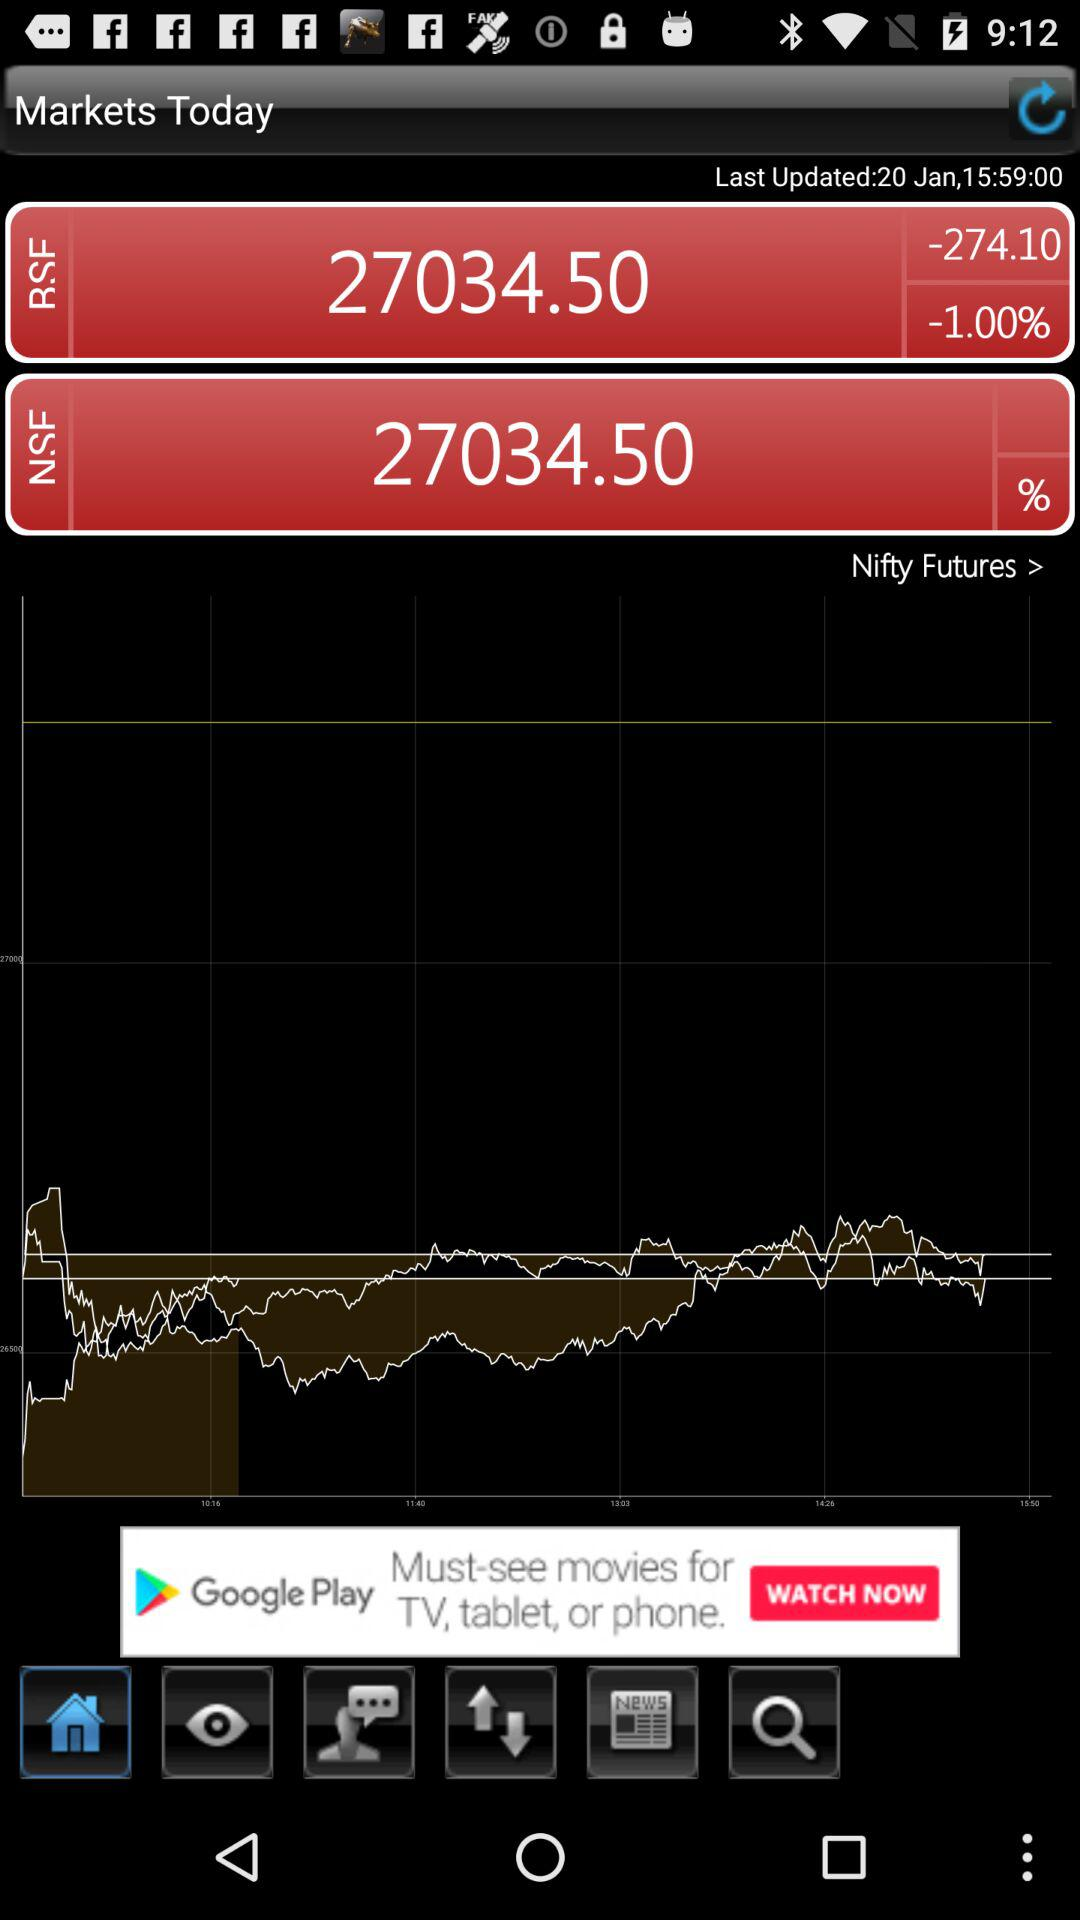What is the percentage change between the two stock values?
Answer the question using a single word or phrase. -1.00% 